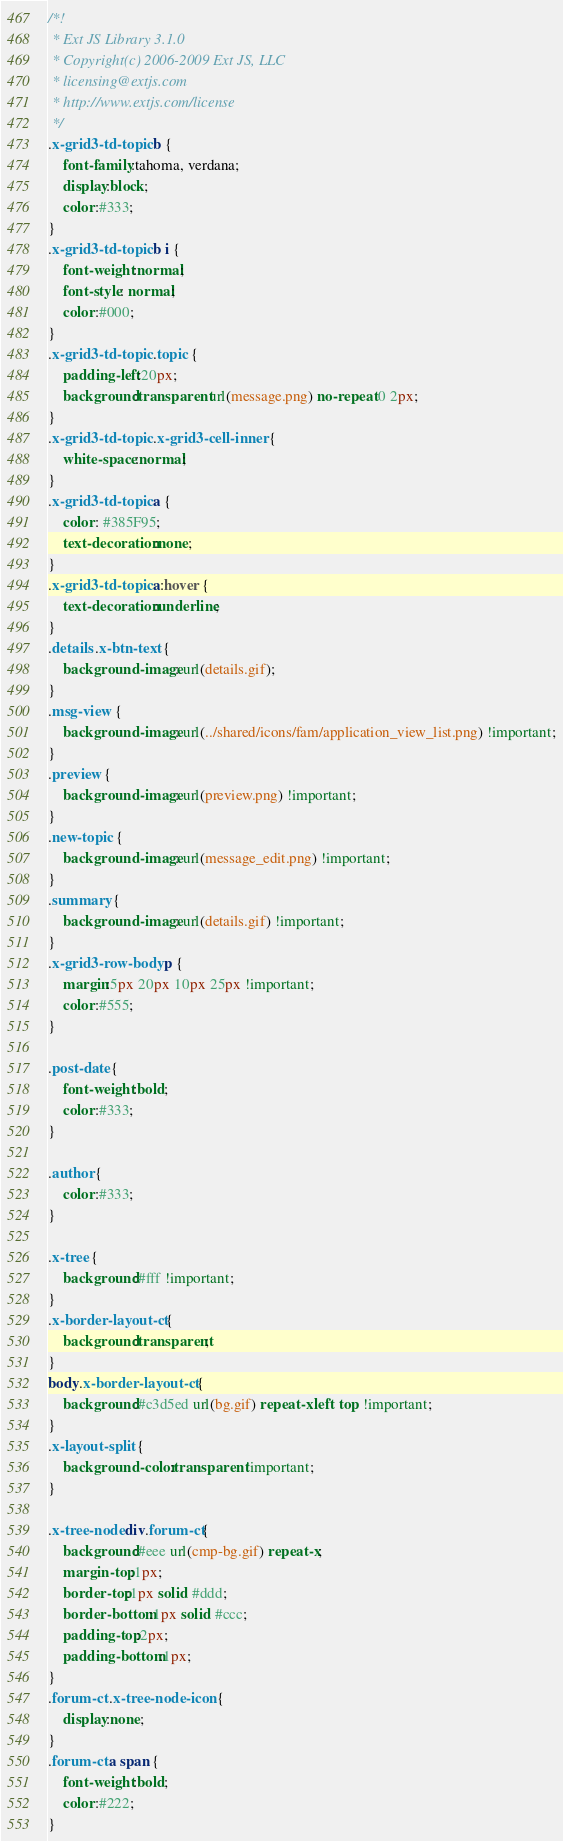Convert code to text. <code><loc_0><loc_0><loc_500><loc_500><_CSS_>/*!
 * Ext JS Library 3.1.0
 * Copyright(c) 2006-2009 Ext JS, LLC
 * licensing@extjs.com
 * http://www.extjs.com/license
 */
.x-grid3-td-topic b {
    font-family:tahoma, verdana;
    display:block;
    color:#333;
}
.x-grid3-td-topic b i {
    font-weight:normal;
    font-style: normal;
    color:#000;
}
.x-grid3-td-topic .topic {
    padding-left:20px;
    background:transparent url(message.png) no-repeat 0 2px;
}
.x-grid3-td-topic .x-grid3-cell-inner {
    white-space:normal;
}
.x-grid3-td-topic a {
    color: #385F95;
    text-decoration:none;
}
.x-grid3-td-topic a:hover {
    text-decoration:underline;
}
.details .x-btn-text {
    background-image: url(details.gif);
}
.msg-view {
    background-image: url(../shared/icons/fam/application_view_list.png) !important;
}
.preview {
    background-image: url(preview.png) !important;
}
.new-topic {
    background-image: url(message_edit.png) !important;
}
.summary {
    background-image: url(details.gif) !important;
}
.x-grid3-row-body p {
    margin:5px 20px 10px 25px !important;
    color:#555;
}

.post-date {
    font-weight:bold;
    color:#333;
}

.author {
    color:#333;
}

.x-tree {
    background:#fff !important;
}
.x-border-layout-ct {
    background:transparent;
}
body.x-border-layout-ct {
    background:#c3d5ed url(bg.gif) repeat-x left top !important;
}
.x-layout-split {
    background-color:transparent !important;
}

.x-tree-node div.forum-ct{
    background:#eee url(cmp-bg.gif) repeat-x;
    margin-top:1px;
    border-top:1px solid #ddd;
    border-bottom:1px solid #ccc;
    padding-top:2px;
    padding-bottom:1px;
}
.forum-ct .x-tree-node-icon {
    display:none;
}
.forum-ct a span {
    font-weight:bold;
    color:#222;
}</code> 